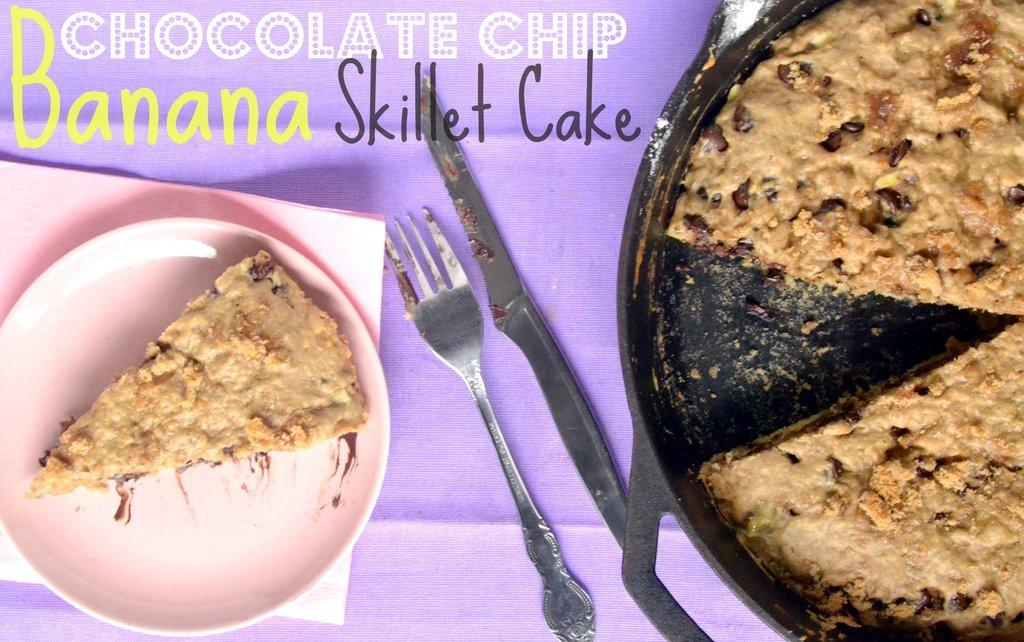What is the main food item in the image? There is a cake in the image. Is there any cake that has been served or cut? Yes, there is a piece of cake on a plate. Where is the plate with the cake located? The plate with the cake is on the left side of the image. What utensils are present in the image? There is a knife and a fork in the image. Where are the knife and fork placed? The knife and fork are on a table. What can be seen at the top of the image? There is text at the top of the image. What type of hook is used to hang the question on the wall in the image? There is no hook or question present in the image. How does the cake show respect to the guests in the image? The cake does not show respect to the guests in the image; it is simply a dessert item. 